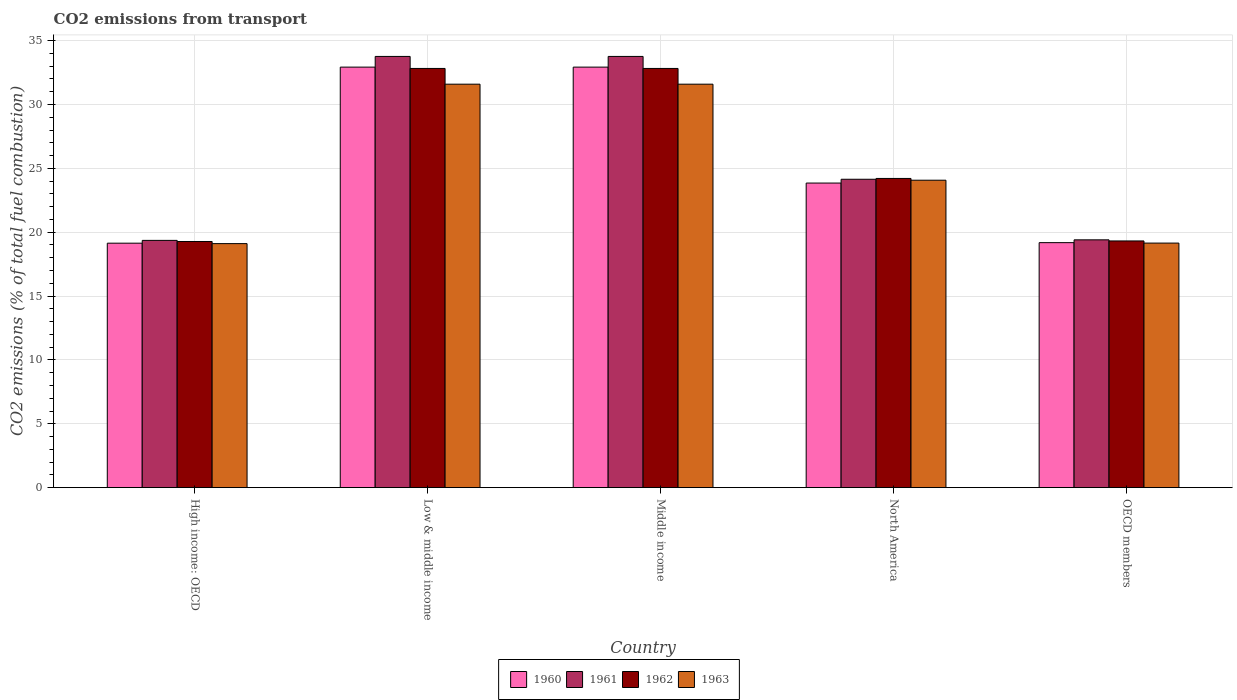How many groups of bars are there?
Ensure brevity in your answer.  5. Are the number of bars on each tick of the X-axis equal?
Provide a short and direct response. Yes. How many bars are there on the 2nd tick from the left?
Keep it short and to the point. 4. How many bars are there on the 5th tick from the right?
Your response must be concise. 4. What is the label of the 1st group of bars from the left?
Your answer should be very brief. High income: OECD. What is the total CO2 emitted in 1961 in Low & middle income?
Give a very brief answer. 33.76. Across all countries, what is the maximum total CO2 emitted in 1961?
Your answer should be very brief. 33.76. Across all countries, what is the minimum total CO2 emitted in 1960?
Offer a very short reply. 19.14. In which country was the total CO2 emitted in 1963 minimum?
Your answer should be compact. High income: OECD. What is the total total CO2 emitted in 1960 in the graph?
Provide a succinct answer. 128.03. What is the difference between the total CO2 emitted in 1962 in Low & middle income and that in OECD members?
Keep it short and to the point. 13.51. What is the difference between the total CO2 emitted in 1961 in Low & middle income and the total CO2 emitted in 1963 in Middle income?
Make the answer very short. 2.17. What is the average total CO2 emitted in 1963 per country?
Offer a terse response. 25.1. What is the difference between the total CO2 emitted of/in 1962 and total CO2 emitted of/in 1963 in Low & middle income?
Offer a very short reply. 1.23. What is the ratio of the total CO2 emitted in 1960 in High income: OECD to that in OECD members?
Provide a short and direct response. 1. Is the total CO2 emitted in 1963 in Low & middle income less than that in OECD members?
Give a very brief answer. No. Is the difference between the total CO2 emitted in 1962 in Middle income and OECD members greater than the difference between the total CO2 emitted in 1963 in Middle income and OECD members?
Provide a succinct answer. Yes. What is the difference between the highest and the second highest total CO2 emitted in 1961?
Offer a terse response. -9.62. What is the difference between the highest and the lowest total CO2 emitted in 1961?
Keep it short and to the point. 14.4. Is it the case that in every country, the sum of the total CO2 emitted in 1962 and total CO2 emitted in 1961 is greater than the sum of total CO2 emitted in 1963 and total CO2 emitted in 1960?
Ensure brevity in your answer.  No. What does the 4th bar from the left in Low & middle income represents?
Give a very brief answer. 1963. Is it the case that in every country, the sum of the total CO2 emitted in 1961 and total CO2 emitted in 1960 is greater than the total CO2 emitted in 1963?
Provide a succinct answer. Yes. How many countries are there in the graph?
Provide a short and direct response. 5. What is the difference between two consecutive major ticks on the Y-axis?
Keep it short and to the point. 5. Are the values on the major ticks of Y-axis written in scientific E-notation?
Offer a terse response. No. Does the graph contain grids?
Your response must be concise. Yes. Where does the legend appear in the graph?
Provide a short and direct response. Bottom center. How are the legend labels stacked?
Make the answer very short. Horizontal. What is the title of the graph?
Your answer should be very brief. CO2 emissions from transport. What is the label or title of the Y-axis?
Your answer should be compact. CO2 emissions (% of total fuel combustion). What is the CO2 emissions (% of total fuel combustion) of 1960 in High income: OECD?
Your answer should be compact. 19.14. What is the CO2 emissions (% of total fuel combustion) in 1961 in High income: OECD?
Offer a terse response. 19.36. What is the CO2 emissions (% of total fuel combustion) of 1962 in High income: OECD?
Keep it short and to the point. 19.27. What is the CO2 emissions (% of total fuel combustion) of 1963 in High income: OECD?
Give a very brief answer. 19.11. What is the CO2 emissions (% of total fuel combustion) of 1960 in Low & middle income?
Offer a very short reply. 32.93. What is the CO2 emissions (% of total fuel combustion) of 1961 in Low & middle income?
Your response must be concise. 33.76. What is the CO2 emissions (% of total fuel combustion) of 1962 in Low & middle income?
Keep it short and to the point. 32.82. What is the CO2 emissions (% of total fuel combustion) of 1963 in Low & middle income?
Ensure brevity in your answer.  31.59. What is the CO2 emissions (% of total fuel combustion) in 1960 in Middle income?
Offer a terse response. 32.93. What is the CO2 emissions (% of total fuel combustion) in 1961 in Middle income?
Offer a terse response. 33.76. What is the CO2 emissions (% of total fuel combustion) in 1962 in Middle income?
Provide a short and direct response. 32.82. What is the CO2 emissions (% of total fuel combustion) in 1963 in Middle income?
Make the answer very short. 31.59. What is the CO2 emissions (% of total fuel combustion) of 1960 in North America?
Make the answer very short. 23.85. What is the CO2 emissions (% of total fuel combustion) of 1961 in North America?
Your answer should be very brief. 24.15. What is the CO2 emissions (% of total fuel combustion) in 1962 in North America?
Keep it short and to the point. 24.21. What is the CO2 emissions (% of total fuel combustion) of 1963 in North America?
Your answer should be compact. 24.07. What is the CO2 emissions (% of total fuel combustion) in 1960 in OECD members?
Your answer should be compact. 19.18. What is the CO2 emissions (% of total fuel combustion) in 1961 in OECD members?
Ensure brevity in your answer.  19.4. What is the CO2 emissions (% of total fuel combustion) of 1962 in OECD members?
Offer a very short reply. 19.32. What is the CO2 emissions (% of total fuel combustion) of 1963 in OECD members?
Your answer should be very brief. 19.15. Across all countries, what is the maximum CO2 emissions (% of total fuel combustion) in 1960?
Offer a terse response. 32.93. Across all countries, what is the maximum CO2 emissions (% of total fuel combustion) in 1961?
Make the answer very short. 33.76. Across all countries, what is the maximum CO2 emissions (% of total fuel combustion) of 1962?
Offer a very short reply. 32.82. Across all countries, what is the maximum CO2 emissions (% of total fuel combustion) of 1963?
Your response must be concise. 31.59. Across all countries, what is the minimum CO2 emissions (% of total fuel combustion) of 1960?
Provide a short and direct response. 19.14. Across all countries, what is the minimum CO2 emissions (% of total fuel combustion) of 1961?
Your answer should be compact. 19.36. Across all countries, what is the minimum CO2 emissions (% of total fuel combustion) of 1962?
Offer a terse response. 19.27. Across all countries, what is the minimum CO2 emissions (% of total fuel combustion) of 1963?
Ensure brevity in your answer.  19.11. What is the total CO2 emissions (% of total fuel combustion) of 1960 in the graph?
Your answer should be compact. 128.03. What is the total CO2 emissions (% of total fuel combustion) in 1961 in the graph?
Your response must be concise. 130.44. What is the total CO2 emissions (% of total fuel combustion) in 1962 in the graph?
Offer a very short reply. 128.45. What is the total CO2 emissions (% of total fuel combustion) of 1963 in the graph?
Your response must be concise. 125.51. What is the difference between the CO2 emissions (% of total fuel combustion) in 1960 in High income: OECD and that in Low & middle income?
Offer a very short reply. -13.79. What is the difference between the CO2 emissions (% of total fuel combustion) in 1961 in High income: OECD and that in Low & middle income?
Ensure brevity in your answer.  -14.4. What is the difference between the CO2 emissions (% of total fuel combustion) of 1962 in High income: OECD and that in Low & middle income?
Your response must be concise. -13.55. What is the difference between the CO2 emissions (% of total fuel combustion) of 1963 in High income: OECD and that in Low & middle income?
Offer a very short reply. -12.48. What is the difference between the CO2 emissions (% of total fuel combustion) of 1960 in High income: OECD and that in Middle income?
Provide a short and direct response. -13.79. What is the difference between the CO2 emissions (% of total fuel combustion) in 1961 in High income: OECD and that in Middle income?
Provide a succinct answer. -14.4. What is the difference between the CO2 emissions (% of total fuel combustion) in 1962 in High income: OECD and that in Middle income?
Keep it short and to the point. -13.55. What is the difference between the CO2 emissions (% of total fuel combustion) of 1963 in High income: OECD and that in Middle income?
Your response must be concise. -12.48. What is the difference between the CO2 emissions (% of total fuel combustion) of 1960 in High income: OECD and that in North America?
Keep it short and to the point. -4.71. What is the difference between the CO2 emissions (% of total fuel combustion) in 1961 in High income: OECD and that in North America?
Your answer should be compact. -4.79. What is the difference between the CO2 emissions (% of total fuel combustion) in 1962 in High income: OECD and that in North America?
Offer a very short reply. -4.94. What is the difference between the CO2 emissions (% of total fuel combustion) of 1963 in High income: OECD and that in North America?
Offer a very short reply. -4.96. What is the difference between the CO2 emissions (% of total fuel combustion) in 1960 in High income: OECD and that in OECD members?
Offer a terse response. -0.04. What is the difference between the CO2 emissions (% of total fuel combustion) in 1961 in High income: OECD and that in OECD members?
Make the answer very short. -0.04. What is the difference between the CO2 emissions (% of total fuel combustion) of 1962 in High income: OECD and that in OECD members?
Ensure brevity in your answer.  -0.04. What is the difference between the CO2 emissions (% of total fuel combustion) in 1963 in High income: OECD and that in OECD members?
Ensure brevity in your answer.  -0.04. What is the difference between the CO2 emissions (% of total fuel combustion) of 1960 in Low & middle income and that in Middle income?
Give a very brief answer. 0. What is the difference between the CO2 emissions (% of total fuel combustion) in 1961 in Low & middle income and that in Middle income?
Give a very brief answer. 0. What is the difference between the CO2 emissions (% of total fuel combustion) of 1963 in Low & middle income and that in Middle income?
Provide a succinct answer. 0. What is the difference between the CO2 emissions (% of total fuel combustion) of 1960 in Low & middle income and that in North America?
Your answer should be very brief. 9.08. What is the difference between the CO2 emissions (% of total fuel combustion) in 1961 in Low & middle income and that in North America?
Ensure brevity in your answer.  9.62. What is the difference between the CO2 emissions (% of total fuel combustion) of 1962 in Low & middle income and that in North America?
Your answer should be compact. 8.61. What is the difference between the CO2 emissions (% of total fuel combustion) in 1963 in Low & middle income and that in North America?
Provide a succinct answer. 7.52. What is the difference between the CO2 emissions (% of total fuel combustion) in 1960 in Low & middle income and that in OECD members?
Provide a succinct answer. 13.75. What is the difference between the CO2 emissions (% of total fuel combustion) of 1961 in Low & middle income and that in OECD members?
Offer a terse response. 14.36. What is the difference between the CO2 emissions (% of total fuel combustion) of 1962 in Low & middle income and that in OECD members?
Keep it short and to the point. 13.51. What is the difference between the CO2 emissions (% of total fuel combustion) in 1963 in Low & middle income and that in OECD members?
Offer a terse response. 12.44. What is the difference between the CO2 emissions (% of total fuel combustion) in 1960 in Middle income and that in North America?
Ensure brevity in your answer.  9.08. What is the difference between the CO2 emissions (% of total fuel combustion) of 1961 in Middle income and that in North America?
Offer a terse response. 9.62. What is the difference between the CO2 emissions (% of total fuel combustion) of 1962 in Middle income and that in North America?
Make the answer very short. 8.61. What is the difference between the CO2 emissions (% of total fuel combustion) of 1963 in Middle income and that in North America?
Keep it short and to the point. 7.52. What is the difference between the CO2 emissions (% of total fuel combustion) of 1960 in Middle income and that in OECD members?
Your response must be concise. 13.75. What is the difference between the CO2 emissions (% of total fuel combustion) in 1961 in Middle income and that in OECD members?
Your answer should be compact. 14.36. What is the difference between the CO2 emissions (% of total fuel combustion) in 1962 in Middle income and that in OECD members?
Your answer should be compact. 13.51. What is the difference between the CO2 emissions (% of total fuel combustion) in 1963 in Middle income and that in OECD members?
Your response must be concise. 12.44. What is the difference between the CO2 emissions (% of total fuel combustion) of 1960 in North America and that in OECD members?
Make the answer very short. 4.67. What is the difference between the CO2 emissions (% of total fuel combustion) of 1961 in North America and that in OECD members?
Ensure brevity in your answer.  4.74. What is the difference between the CO2 emissions (% of total fuel combustion) of 1962 in North America and that in OECD members?
Provide a short and direct response. 4.89. What is the difference between the CO2 emissions (% of total fuel combustion) of 1963 in North America and that in OECD members?
Keep it short and to the point. 4.92. What is the difference between the CO2 emissions (% of total fuel combustion) in 1960 in High income: OECD and the CO2 emissions (% of total fuel combustion) in 1961 in Low & middle income?
Provide a succinct answer. -14.62. What is the difference between the CO2 emissions (% of total fuel combustion) of 1960 in High income: OECD and the CO2 emissions (% of total fuel combustion) of 1962 in Low & middle income?
Provide a short and direct response. -13.68. What is the difference between the CO2 emissions (% of total fuel combustion) in 1960 in High income: OECD and the CO2 emissions (% of total fuel combustion) in 1963 in Low & middle income?
Offer a very short reply. -12.45. What is the difference between the CO2 emissions (% of total fuel combustion) in 1961 in High income: OECD and the CO2 emissions (% of total fuel combustion) in 1962 in Low & middle income?
Keep it short and to the point. -13.46. What is the difference between the CO2 emissions (% of total fuel combustion) in 1961 in High income: OECD and the CO2 emissions (% of total fuel combustion) in 1963 in Low & middle income?
Your answer should be compact. -12.23. What is the difference between the CO2 emissions (% of total fuel combustion) of 1962 in High income: OECD and the CO2 emissions (% of total fuel combustion) of 1963 in Low & middle income?
Make the answer very short. -12.32. What is the difference between the CO2 emissions (% of total fuel combustion) in 1960 in High income: OECD and the CO2 emissions (% of total fuel combustion) in 1961 in Middle income?
Your answer should be compact. -14.62. What is the difference between the CO2 emissions (% of total fuel combustion) of 1960 in High income: OECD and the CO2 emissions (% of total fuel combustion) of 1962 in Middle income?
Make the answer very short. -13.68. What is the difference between the CO2 emissions (% of total fuel combustion) in 1960 in High income: OECD and the CO2 emissions (% of total fuel combustion) in 1963 in Middle income?
Your answer should be compact. -12.45. What is the difference between the CO2 emissions (% of total fuel combustion) of 1961 in High income: OECD and the CO2 emissions (% of total fuel combustion) of 1962 in Middle income?
Give a very brief answer. -13.46. What is the difference between the CO2 emissions (% of total fuel combustion) of 1961 in High income: OECD and the CO2 emissions (% of total fuel combustion) of 1963 in Middle income?
Ensure brevity in your answer.  -12.23. What is the difference between the CO2 emissions (% of total fuel combustion) of 1962 in High income: OECD and the CO2 emissions (% of total fuel combustion) of 1963 in Middle income?
Offer a terse response. -12.32. What is the difference between the CO2 emissions (% of total fuel combustion) in 1960 in High income: OECD and the CO2 emissions (% of total fuel combustion) in 1961 in North America?
Provide a short and direct response. -5.01. What is the difference between the CO2 emissions (% of total fuel combustion) in 1960 in High income: OECD and the CO2 emissions (% of total fuel combustion) in 1962 in North America?
Ensure brevity in your answer.  -5.07. What is the difference between the CO2 emissions (% of total fuel combustion) in 1960 in High income: OECD and the CO2 emissions (% of total fuel combustion) in 1963 in North America?
Keep it short and to the point. -4.93. What is the difference between the CO2 emissions (% of total fuel combustion) in 1961 in High income: OECD and the CO2 emissions (% of total fuel combustion) in 1962 in North America?
Provide a short and direct response. -4.85. What is the difference between the CO2 emissions (% of total fuel combustion) in 1961 in High income: OECD and the CO2 emissions (% of total fuel combustion) in 1963 in North America?
Ensure brevity in your answer.  -4.71. What is the difference between the CO2 emissions (% of total fuel combustion) of 1962 in High income: OECD and the CO2 emissions (% of total fuel combustion) of 1963 in North America?
Offer a very short reply. -4.8. What is the difference between the CO2 emissions (% of total fuel combustion) of 1960 in High income: OECD and the CO2 emissions (% of total fuel combustion) of 1961 in OECD members?
Offer a very short reply. -0.26. What is the difference between the CO2 emissions (% of total fuel combustion) of 1960 in High income: OECD and the CO2 emissions (% of total fuel combustion) of 1962 in OECD members?
Your response must be concise. -0.18. What is the difference between the CO2 emissions (% of total fuel combustion) in 1960 in High income: OECD and the CO2 emissions (% of total fuel combustion) in 1963 in OECD members?
Keep it short and to the point. -0.01. What is the difference between the CO2 emissions (% of total fuel combustion) of 1961 in High income: OECD and the CO2 emissions (% of total fuel combustion) of 1962 in OECD members?
Your answer should be very brief. 0.04. What is the difference between the CO2 emissions (% of total fuel combustion) of 1961 in High income: OECD and the CO2 emissions (% of total fuel combustion) of 1963 in OECD members?
Provide a short and direct response. 0.21. What is the difference between the CO2 emissions (% of total fuel combustion) in 1962 in High income: OECD and the CO2 emissions (% of total fuel combustion) in 1963 in OECD members?
Your answer should be very brief. 0.13. What is the difference between the CO2 emissions (% of total fuel combustion) in 1960 in Low & middle income and the CO2 emissions (% of total fuel combustion) in 1961 in Middle income?
Offer a terse response. -0.84. What is the difference between the CO2 emissions (% of total fuel combustion) of 1960 in Low & middle income and the CO2 emissions (% of total fuel combustion) of 1962 in Middle income?
Provide a short and direct response. 0.1. What is the difference between the CO2 emissions (% of total fuel combustion) of 1960 in Low & middle income and the CO2 emissions (% of total fuel combustion) of 1963 in Middle income?
Offer a very short reply. 1.34. What is the difference between the CO2 emissions (% of total fuel combustion) of 1961 in Low & middle income and the CO2 emissions (% of total fuel combustion) of 1962 in Middle income?
Give a very brief answer. 0.94. What is the difference between the CO2 emissions (% of total fuel combustion) in 1961 in Low & middle income and the CO2 emissions (% of total fuel combustion) in 1963 in Middle income?
Your answer should be compact. 2.17. What is the difference between the CO2 emissions (% of total fuel combustion) in 1962 in Low & middle income and the CO2 emissions (% of total fuel combustion) in 1963 in Middle income?
Ensure brevity in your answer.  1.23. What is the difference between the CO2 emissions (% of total fuel combustion) in 1960 in Low & middle income and the CO2 emissions (% of total fuel combustion) in 1961 in North America?
Your response must be concise. 8.78. What is the difference between the CO2 emissions (% of total fuel combustion) of 1960 in Low & middle income and the CO2 emissions (% of total fuel combustion) of 1962 in North America?
Provide a succinct answer. 8.72. What is the difference between the CO2 emissions (% of total fuel combustion) in 1960 in Low & middle income and the CO2 emissions (% of total fuel combustion) in 1963 in North America?
Offer a very short reply. 8.86. What is the difference between the CO2 emissions (% of total fuel combustion) in 1961 in Low & middle income and the CO2 emissions (% of total fuel combustion) in 1962 in North America?
Ensure brevity in your answer.  9.55. What is the difference between the CO2 emissions (% of total fuel combustion) of 1961 in Low & middle income and the CO2 emissions (% of total fuel combustion) of 1963 in North America?
Make the answer very short. 9.69. What is the difference between the CO2 emissions (% of total fuel combustion) in 1962 in Low & middle income and the CO2 emissions (% of total fuel combustion) in 1963 in North America?
Your answer should be compact. 8.75. What is the difference between the CO2 emissions (% of total fuel combustion) of 1960 in Low & middle income and the CO2 emissions (% of total fuel combustion) of 1961 in OECD members?
Your answer should be very brief. 13.53. What is the difference between the CO2 emissions (% of total fuel combustion) of 1960 in Low & middle income and the CO2 emissions (% of total fuel combustion) of 1962 in OECD members?
Your answer should be very brief. 13.61. What is the difference between the CO2 emissions (% of total fuel combustion) in 1960 in Low & middle income and the CO2 emissions (% of total fuel combustion) in 1963 in OECD members?
Keep it short and to the point. 13.78. What is the difference between the CO2 emissions (% of total fuel combustion) in 1961 in Low & middle income and the CO2 emissions (% of total fuel combustion) in 1962 in OECD members?
Your response must be concise. 14.45. What is the difference between the CO2 emissions (% of total fuel combustion) in 1961 in Low & middle income and the CO2 emissions (% of total fuel combustion) in 1963 in OECD members?
Provide a succinct answer. 14.62. What is the difference between the CO2 emissions (% of total fuel combustion) in 1962 in Low & middle income and the CO2 emissions (% of total fuel combustion) in 1963 in OECD members?
Ensure brevity in your answer.  13.68. What is the difference between the CO2 emissions (% of total fuel combustion) in 1960 in Middle income and the CO2 emissions (% of total fuel combustion) in 1961 in North America?
Your answer should be very brief. 8.78. What is the difference between the CO2 emissions (% of total fuel combustion) of 1960 in Middle income and the CO2 emissions (% of total fuel combustion) of 1962 in North America?
Offer a terse response. 8.72. What is the difference between the CO2 emissions (% of total fuel combustion) of 1960 in Middle income and the CO2 emissions (% of total fuel combustion) of 1963 in North America?
Offer a very short reply. 8.86. What is the difference between the CO2 emissions (% of total fuel combustion) of 1961 in Middle income and the CO2 emissions (% of total fuel combustion) of 1962 in North America?
Ensure brevity in your answer.  9.55. What is the difference between the CO2 emissions (% of total fuel combustion) of 1961 in Middle income and the CO2 emissions (% of total fuel combustion) of 1963 in North America?
Provide a short and direct response. 9.69. What is the difference between the CO2 emissions (% of total fuel combustion) of 1962 in Middle income and the CO2 emissions (% of total fuel combustion) of 1963 in North America?
Provide a succinct answer. 8.75. What is the difference between the CO2 emissions (% of total fuel combustion) in 1960 in Middle income and the CO2 emissions (% of total fuel combustion) in 1961 in OECD members?
Make the answer very short. 13.53. What is the difference between the CO2 emissions (% of total fuel combustion) of 1960 in Middle income and the CO2 emissions (% of total fuel combustion) of 1962 in OECD members?
Your response must be concise. 13.61. What is the difference between the CO2 emissions (% of total fuel combustion) of 1960 in Middle income and the CO2 emissions (% of total fuel combustion) of 1963 in OECD members?
Your answer should be very brief. 13.78. What is the difference between the CO2 emissions (% of total fuel combustion) in 1961 in Middle income and the CO2 emissions (% of total fuel combustion) in 1962 in OECD members?
Give a very brief answer. 14.45. What is the difference between the CO2 emissions (% of total fuel combustion) of 1961 in Middle income and the CO2 emissions (% of total fuel combustion) of 1963 in OECD members?
Your response must be concise. 14.62. What is the difference between the CO2 emissions (% of total fuel combustion) of 1962 in Middle income and the CO2 emissions (% of total fuel combustion) of 1963 in OECD members?
Offer a very short reply. 13.68. What is the difference between the CO2 emissions (% of total fuel combustion) of 1960 in North America and the CO2 emissions (% of total fuel combustion) of 1961 in OECD members?
Give a very brief answer. 4.45. What is the difference between the CO2 emissions (% of total fuel combustion) of 1960 in North America and the CO2 emissions (% of total fuel combustion) of 1962 in OECD members?
Ensure brevity in your answer.  4.53. What is the difference between the CO2 emissions (% of total fuel combustion) in 1960 in North America and the CO2 emissions (% of total fuel combustion) in 1963 in OECD members?
Ensure brevity in your answer.  4.7. What is the difference between the CO2 emissions (% of total fuel combustion) in 1961 in North America and the CO2 emissions (% of total fuel combustion) in 1962 in OECD members?
Your answer should be very brief. 4.83. What is the difference between the CO2 emissions (% of total fuel combustion) of 1961 in North America and the CO2 emissions (% of total fuel combustion) of 1963 in OECD members?
Provide a short and direct response. 5. What is the difference between the CO2 emissions (% of total fuel combustion) of 1962 in North America and the CO2 emissions (% of total fuel combustion) of 1963 in OECD members?
Provide a short and direct response. 5.06. What is the average CO2 emissions (% of total fuel combustion) in 1960 per country?
Your response must be concise. 25.61. What is the average CO2 emissions (% of total fuel combustion) in 1961 per country?
Your answer should be very brief. 26.09. What is the average CO2 emissions (% of total fuel combustion) of 1962 per country?
Offer a very short reply. 25.69. What is the average CO2 emissions (% of total fuel combustion) of 1963 per country?
Make the answer very short. 25.1. What is the difference between the CO2 emissions (% of total fuel combustion) in 1960 and CO2 emissions (% of total fuel combustion) in 1961 in High income: OECD?
Offer a very short reply. -0.22. What is the difference between the CO2 emissions (% of total fuel combustion) in 1960 and CO2 emissions (% of total fuel combustion) in 1962 in High income: OECD?
Make the answer very short. -0.13. What is the difference between the CO2 emissions (% of total fuel combustion) in 1960 and CO2 emissions (% of total fuel combustion) in 1963 in High income: OECD?
Your answer should be compact. 0.03. What is the difference between the CO2 emissions (% of total fuel combustion) in 1961 and CO2 emissions (% of total fuel combustion) in 1962 in High income: OECD?
Ensure brevity in your answer.  0.09. What is the difference between the CO2 emissions (% of total fuel combustion) in 1961 and CO2 emissions (% of total fuel combustion) in 1963 in High income: OECD?
Give a very brief answer. 0.25. What is the difference between the CO2 emissions (% of total fuel combustion) in 1962 and CO2 emissions (% of total fuel combustion) in 1963 in High income: OECD?
Ensure brevity in your answer.  0.17. What is the difference between the CO2 emissions (% of total fuel combustion) in 1960 and CO2 emissions (% of total fuel combustion) in 1961 in Low & middle income?
Make the answer very short. -0.84. What is the difference between the CO2 emissions (% of total fuel combustion) in 1960 and CO2 emissions (% of total fuel combustion) in 1962 in Low & middle income?
Make the answer very short. 0.1. What is the difference between the CO2 emissions (% of total fuel combustion) in 1960 and CO2 emissions (% of total fuel combustion) in 1963 in Low & middle income?
Your answer should be compact. 1.34. What is the difference between the CO2 emissions (% of total fuel combustion) of 1961 and CO2 emissions (% of total fuel combustion) of 1962 in Low & middle income?
Your answer should be compact. 0.94. What is the difference between the CO2 emissions (% of total fuel combustion) of 1961 and CO2 emissions (% of total fuel combustion) of 1963 in Low & middle income?
Offer a very short reply. 2.17. What is the difference between the CO2 emissions (% of total fuel combustion) in 1962 and CO2 emissions (% of total fuel combustion) in 1963 in Low & middle income?
Give a very brief answer. 1.23. What is the difference between the CO2 emissions (% of total fuel combustion) in 1960 and CO2 emissions (% of total fuel combustion) in 1961 in Middle income?
Ensure brevity in your answer.  -0.84. What is the difference between the CO2 emissions (% of total fuel combustion) of 1960 and CO2 emissions (% of total fuel combustion) of 1962 in Middle income?
Give a very brief answer. 0.1. What is the difference between the CO2 emissions (% of total fuel combustion) of 1960 and CO2 emissions (% of total fuel combustion) of 1963 in Middle income?
Ensure brevity in your answer.  1.34. What is the difference between the CO2 emissions (% of total fuel combustion) in 1961 and CO2 emissions (% of total fuel combustion) in 1962 in Middle income?
Offer a terse response. 0.94. What is the difference between the CO2 emissions (% of total fuel combustion) in 1961 and CO2 emissions (% of total fuel combustion) in 1963 in Middle income?
Offer a very short reply. 2.17. What is the difference between the CO2 emissions (% of total fuel combustion) in 1962 and CO2 emissions (% of total fuel combustion) in 1963 in Middle income?
Ensure brevity in your answer.  1.23. What is the difference between the CO2 emissions (% of total fuel combustion) of 1960 and CO2 emissions (% of total fuel combustion) of 1961 in North America?
Make the answer very short. -0.3. What is the difference between the CO2 emissions (% of total fuel combustion) of 1960 and CO2 emissions (% of total fuel combustion) of 1962 in North America?
Offer a very short reply. -0.36. What is the difference between the CO2 emissions (% of total fuel combustion) of 1960 and CO2 emissions (% of total fuel combustion) of 1963 in North America?
Your answer should be very brief. -0.22. What is the difference between the CO2 emissions (% of total fuel combustion) of 1961 and CO2 emissions (% of total fuel combustion) of 1962 in North America?
Your answer should be compact. -0.06. What is the difference between the CO2 emissions (% of total fuel combustion) in 1961 and CO2 emissions (% of total fuel combustion) in 1963 in North America?
Keep it short and to the point. 0.07. What is the difference between the CO2 emissions (% of total fuel combustion) of 1962 and CO2 emissions (% of total fuel combustion) of 1963 in North America?
Provide a short and direct response. 0.14. What is the difference between the CO2 emissions (% of total fuel combustion) in 1960 and CO2 emissions (% of total fuel combustion) in 1961 in OECD members?
Provide a succinct answer. -0.22. What is the difference between the CO2 emissions (% of total fuel combustion) of 1960 and CO2 emissions (% of total fuel combustion) of 1962 in OECD members?
Offer a terse response. -0.13. What is the difference between the CO2 emissions (% of total fuel combustion) in 1960 and CO2 emissions (% of total fuel combustion) in 1963 in OECD members?
Ensure brevity in your answer.  0.03. What is the difference between the CO2 emissions (% of total fuel combustion) of 1961 and CO2 emissions (% of total fuel combustion) of 1962 in OECD members?
Offer a terse response. 0.09. What is the difference between the CO2 emissions (% of total fuel combustion) in 1961 and CO2 emissions (% of total fuel combustion) in 1963 in OECD members?
Keep it short and to the point. 0.25. What is the difference between the CO2 emissions (% of total fuel combustion) of 1962 and CO2 emissions (% of total fuel combustion) of 1963 in OECD members?
Offer a very short reply. 0.17. What is the ratio of the CO2 emissions (% of total fuel combustion) of 1960 in High income: OECD to that in Low & middle income?
Provide a succinct answer. 0.58. What is the ratio of the CO2 emissions (% of total fuel combustion) in 1961 in High income: OECD to that in Low & middle income?
Offer a terse response. 0.57. What is the ratio of the CO2 emissions (% of total fuel combustion) in 1962 in High income: OECD to that in Low & middle income?
Provide a succinct answer. 0.59. What is the ratio of the CO2 emissions (% of total fuel combustion) in 1963 in High income: OECD to that in Low & middle income?
Your answer should be very brief. 0.6. What is the ratio of the CO2 emissions (% of total fuel combustion) in 1960 in High income: OECD to that in Middle income?
Offer a very short reply. 0.58. What is the ratio of the CO2 emissions (% of total fuel combustion) of 1961 in High income: OECD to that in Middle income?
Your answer should be compact. 0.57. What is the ratio of the CO2 emissions (% of total fuel combustion) in 1962 in High income: OECD to that in Middle income?
Your response must be concise. 0.59. What is the ratio of the CO2 emissions (% of total fuel combustion) of 1963 in High income: OECD to that in Middle income?
Make the answer very short. 0.6. What is the ratio of the CO2 emissions (% of total fuel combustion) in 1960 in High income: OECD to that in North America?
Give a very brief answer. 0.8. What is the ratio of the CO2 emissions (% of total fuel combustion) of 1961 in High income: OECD to that in North America?
Provide a succinct answer. 0.8. What is the ratio of the CO2 emissions (% of total fuel combustion) of 1962 in High income: OECD to that in North America?
Offer a very short reply. 0.8. What is the ratio of the CO2 emissions (% of total fuel combustion) in 1963 in High income: OECD to that in North America?
Ensure brevity in your answer.  0.79. What is the ratio of the CO2 emissions (% of total fuel combustion) in 1963 in High income: OECD to that in OECD members?
Ensure brevity in your answer.  1. What is the ratio of the CO2 emissions (% of total fuel combustion) in 1961 in Low & middle income to that in Middle income?
Offer a very short reply. 1. What is the ratio of the CO2 emissions (% of total fuel combustion) in 1960 in Low & middle income to that in North America?
Offer a terse response. 1.38. What is the ratio of the CO2 emissions (% of total fuel combustion) in 1961 in Low & middle income to that in North America?
Provide a succinct answer. 1.4. What is the ratio of the CO2 emissions (% of total fuel combustion) of 1962 in Low & middle income to that in North America?
Offer a very short reply. 1.36. What is the ratio of the CO2 emissions (% of total fuel combustion) of 1963 in Low & middle income to that in North America?
Your answer should be compact. 1.31. What is the ratio of the CO2 emissions (% of total fuel combustion) in 1960 in Low & middle income to that in OECD members?
Your answer should be compact. 1.72. What is the ratio of the CO2 emissions (% of total fuel combustion) of 1961 in Low & middle income to that in OECD members?
Offer a terse response. 1.74. What is the ratio of the CO2 emissions (% of total fuel combustion) of 1962 in Low & middle income to that in OECD members?
Keep it short and to the point. 1.7. What is the ratio of the CO2 emissions (% of total fuel combustion) in 1963 in Low & middle income to that in OECD members?
Your answer should be compact. 1.65. What is the ratio of the CO2 emissions (% of total fuel combustion) of 1960 in Middle income to that in North America?
Offer a very short reply. 1.38. What is the ratio of the CO2 emissions (% of total fuel combustion) of 1961 in Middle income to that in North America?
Offer a terse response. 1.4. What is the ratio of the CO2 emissions (% of total fuel combustion) in 1962 in Middle income to that in North America?
Ensure brevity in your answer.  1.36. What is the ratio of the CO2 emissions (% of total fuel combustion) of 1963 in Middle income to that in North America?
Keep it short and to the point. 1.31. What is the ratio of the CO2 emissions (% of total fuel combustion) of 1960 in Middle income to that in OECD members?
Make the answer very short. 1.72. What is the ratio of the CO2 emissions (% of total fuel combustion) of 1961 in Middle income to that in OECD members?
Offer a very short reply. 1.74. What is the ratio of the CO2 emissions (% of total fuel combustion) in 1962 in Middle income to that in OECD members?
Offer a very short reply. 1.7. What is the ratio of the CO2 emissions (% of total fuel combustion) of 1963 in Middle income to that in OECD members?
Provide a short and direct response. 1.65. What is the ratio of the CO2 emissions (% of total fuel combustion) in 1960 in North America to that in OECD members?
Ensure brevity in your answer.  1.24. What is the ratio of the CO2 emissions (% of total fuel combustion) of 1961 in North America to that in OECD members?
Give a very brief answer. 1.24. What is the ratio of the CO2 emissions (% of total fuel combustion) in 1962 in North America to that in OECD members?
Your answer should be compact. 1.25. What is the ratio of the CO2 emissions (% of total fuel combustion) in 1963 in North America to that in OECD members?
Provide a short and direct response. 1.26. What is the difference between the highest and the second highest CO2 emissions (% of total fuel combustion) of 1961?
Give a very brief answer. 0. What is the difference between the highest and the second highest CO2 emissions (% of total fuel combustion) of 1963?
Your answer should be compact. 0. What is the difference between the highest and the lowest CO2 emissions (% of total fuel combustion) of 1960?
Your answer should be very brief. 13.79. What is the difference between the highest and the lowest CO2 emissions (% of total fuel combustion) in 1961?
Keep it short and to the point. 14.4. What is the difference between the highest and the lowest CO2 emissions (% of total fuel combustion) in 1962?
Your response must be concise. 13.55. What is the difference between the highest and the lowest CO2 emissions (% of total fuel combustion) in 1963?
Make the answer very short. 12.48. 